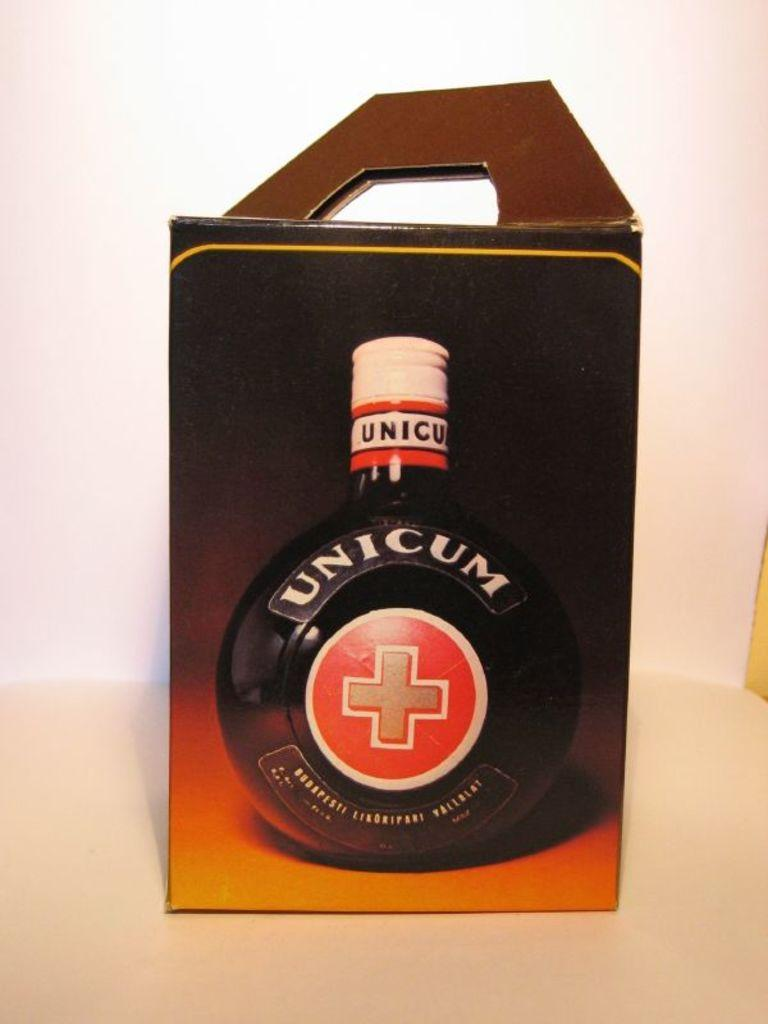What object is the main focus of the image? There is a box in the image. What is depicted on the box? The box has a picture of a bottle on it. What color is the background of the image? The background of the image is white. What type of art is the governor displaying in the image? There is no governor or art present in the image; it only features a box with a picture of a bottle on it against a white background. 